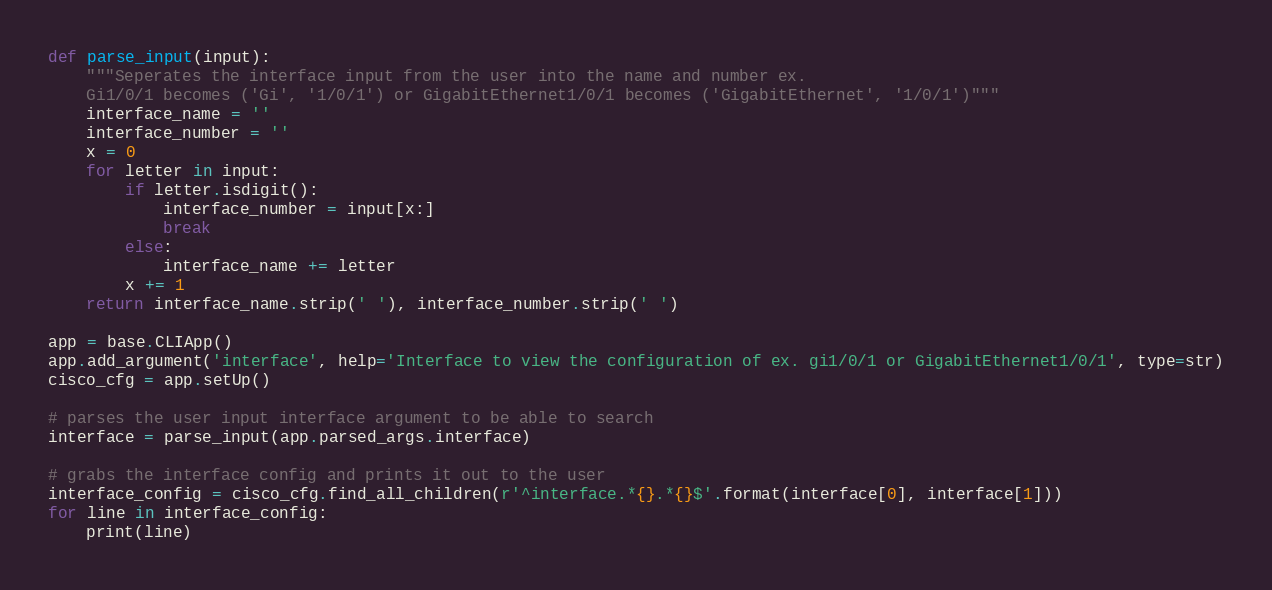Convert code to text. <code><loc_0><loc_0><loc_500><loc_500><_Python_>
def parse_input(input):
    """Seperates the interface input from the user into the name and number ex.
    Gi1/0/1 becomes ('Gi', '1/0/1') or GigabitEthernet1/0/1 becomes ('GigabitEthernet', '1/0/1')"""
    interface_name = ''
    interface_number = ''
    x = 0
    for letter in input:
        if letter.isdigit():
            interface_number = input[x:]
            break
        else:
            interface_name += letter
        x += 1
    return interface_name.strip(' '), interface_number.strip(' ')

app = base.CLIApp()
app.add_argument('interface', help='Interface to view the configuration of ex. gi1/0/1 or GigabitEthernet1/0/1', type=str)
cisco_cfg = app.setUp()

# parses the user input interface argument to be able to search
interface = parse_input(app.parsed_args.interface)

# grabs the interface config and prints it out to the user
interface_config = cisco_cfg.find_all_children(r'^interface.*{}.*{}$'.format(interface[0], interface[1]))
for line in interface_config:
    print(line)</code> 